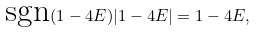<formula> <loc_0><loc_0><loc_500><loc_500>\text {sgn} ( 1 - 4 E ) | 1 - 4 E | = 1 - 4 E ,</formula> 